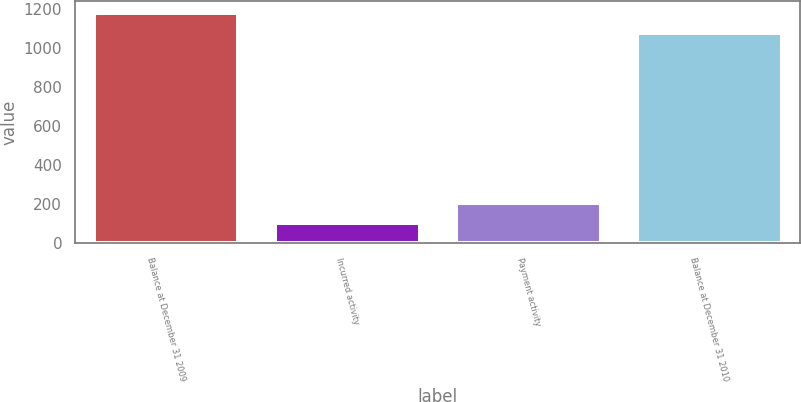Convert chart to OTSL. <chart><loc_0><loc_0><loc_500><loc_500><bar_chart><fcel>Balance at December 31 2009<fcel>Incurred activity<fcel>Payment activity<fcel>Balance at December 31 2010<nl><fcel>1180<fcel>103<fcel>205<fcel>1078<nl></chart> 